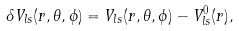Convert formula to latex. <formula><loc_0><loc_0><loc_500><loc_500>\delta V _ { l s } ( r , \theta , \phi ) = V _ { l s } ( r , \theta , \phi ) - V _ { l s } ^ { 0 } ( r ) ,</formula> 